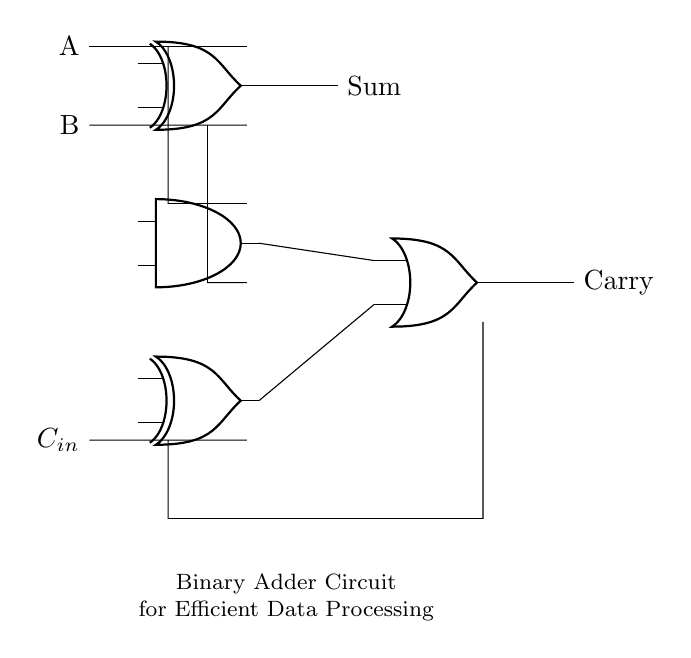What are the inputs to the circuit? The inputs to the circuit are labeled as A and B, which are the two binary values that the adder will process.
Answer: A and B How many logic gates are used in this circuit? There are three types of logic gates used: two XOR gates, one AND gate, and one OR gate, resulting in a total of four gates.
Answer: Four gates What is the output of the XOR gate labeled as Sum? The output of the XOR gate labeled as Sum is the result of the binary addition of inputs A and B, where it produces a high signal (1) if only one of the inputs is high, signifying the sum.
Answer: Sum What does the OR gate represent in the circuit? The OR gate combines the outputs of the AND gate (which computes the carry from A and B) and the second XOR gate (which adds the previous carry) to produce the final carry output.
Answer: Carry What is the significance of the input labeled as C_in? The input labeled as C_in represents the carry-in from a previous stage of addition, enabling the adder to handle multiple-bit binary addition by allowing a carry from the preceding lower significant digit.
Answer: Previous carry How does the AND gate interact with A and B? The AND gate takes inputs A and B to determine if both are high (1), indicating a carry condition that needs to be addressed in the final output.
Answer: Carry output from A and B What does the explanatory text convey about the circuit's purpose? The explanatory text states that this is a Binary Adder Circuit for Efficient Data Processing, highlighting its role in adding binary numbers effectively within data pipelines.
Answer: Efficient Data Processing 